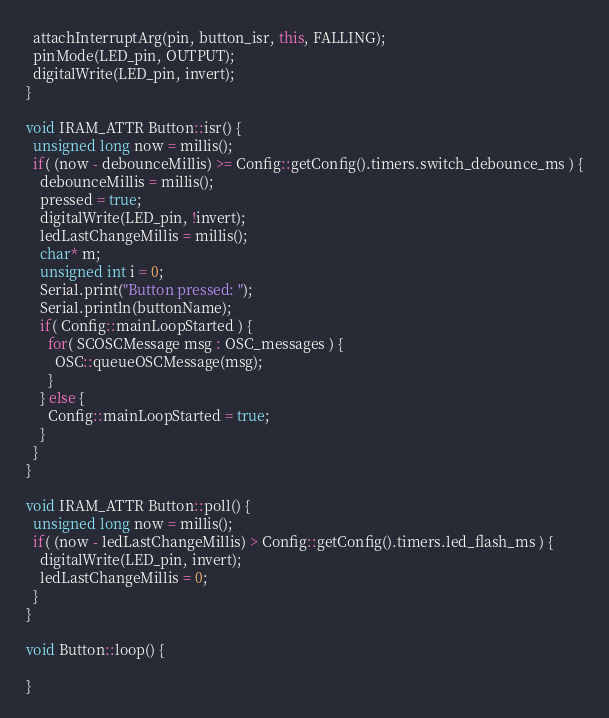<code> <loc_0><loc_0><loc_500><loc_500><_C++_>  attachInterruptArg(pin, button_isr, this, FALLING);
  pinMode(LED_pin, OUTPUT);
  digitalWrite(LED_pin, invert);
}

void IRAM_ATTR Button::isr() {
  unsigned long now = millis();
  if( (now - debounceMillis) >= Config::getConfig().timers.switch_debounce_ms ) {
    debounceMillis = millis();
    pressed = true;
    digitalWrite(LED_pin, !invert);
    ledLastChangeMillis = millis();
    char* m;
    unsigned int i = 0;
    Serial.print("Button pressed: ");
    Serial.println(buttonName);
    if( Config::mainLoopStarted ) { 
      for( SCOSCMessage msg : OSC_messages ) {
        OSC::queueOSCMessage(msg);
      }
    } else {
      Config::mainLoopStarted = true;
    }
  }
}

void IRAM_ATTR Button::poll() {
  unsigned long now = millis();
  if( (now - ledLastChangeMillis) > Config::getConfig().timers.led_flash_ms ) {
    digitalWrite(LED_pin, invert);
    ledLastChangeMillis = 0;
  }
}

void Button::loop() {
  
}
</code> 